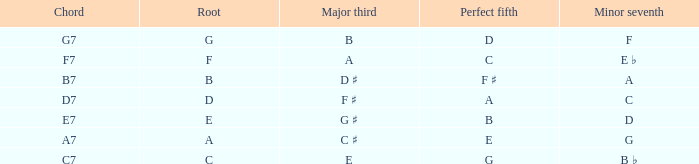Which chord has e as its major third component? C7. 